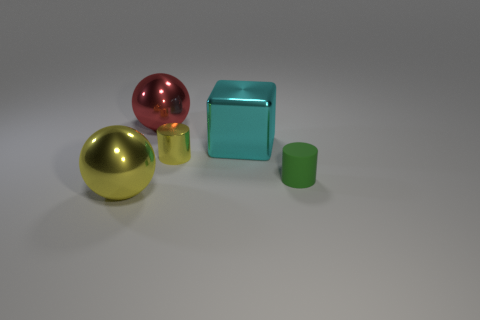Add 4 green matte objects. How many objects exist? 9 Subtract 1 cylinders. How many cylinders are left? 1 Subtract all cubes. How many objects are left? 4 Add 1 small objects. How many small objects exist? 3 Subtract all green cylinders. How many cylinders are left? 1 Subtract 0 purple cylinders. How many objects are left? 5 Subtract all blue cylinders. Subtract all purple blocks. How many cylinders are left? 2 Subtract all blue cubes. How many yellow cylinders are left? 1 Subtract all large spheres. Subtract all small shiny things. How many objects are left? 2 Add 3 tiny green cylinders. How many tiny green cylinders are left? 4 